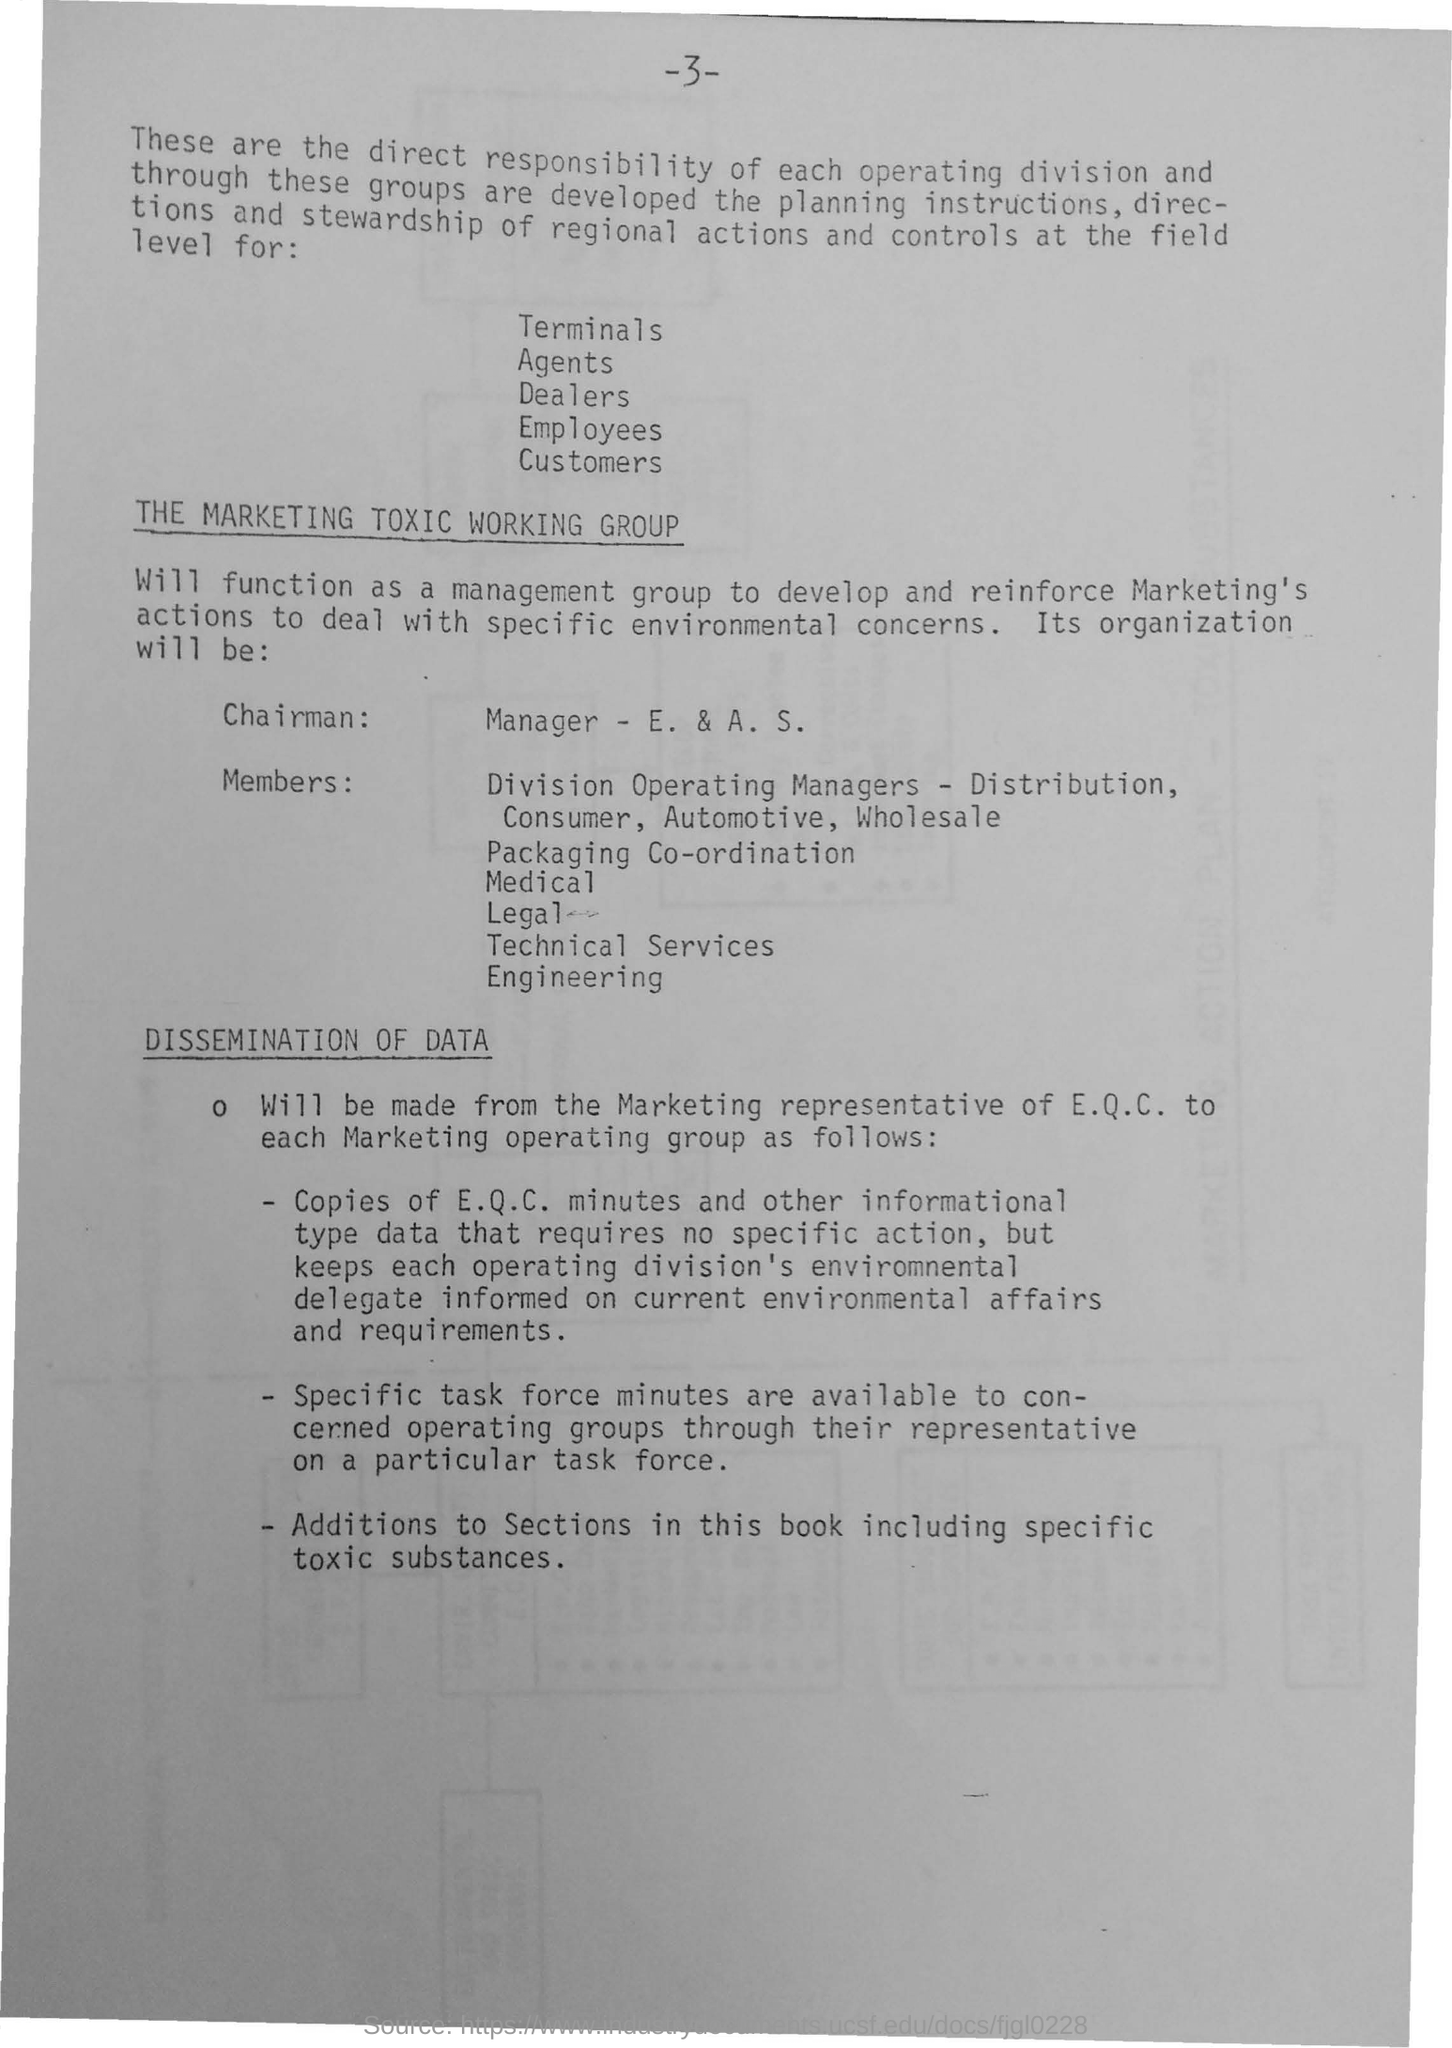Give some essential details in this illustration. The document contains a second title, which is 'Dissemination of Data.' The document is titled "The Marketing Toxic Working Group. 